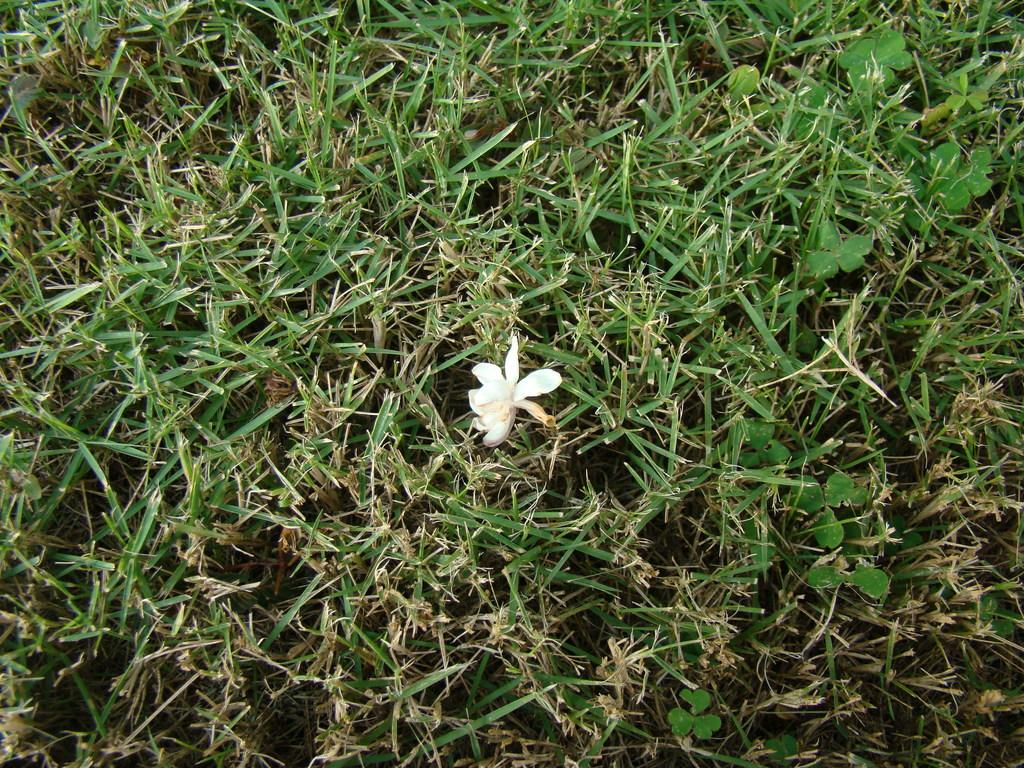What is the main subject of the image? There is a white color flower in the center of the image. What else can be seen in the image besides the flower? There are plants visible in the image. What type of vegetation is present in the image? There is green grass in the image. What type of fruit is being requested by the flower in the image? There is no fruit or request present in the image; it features a white color flower surrounded by plants and green grass. 